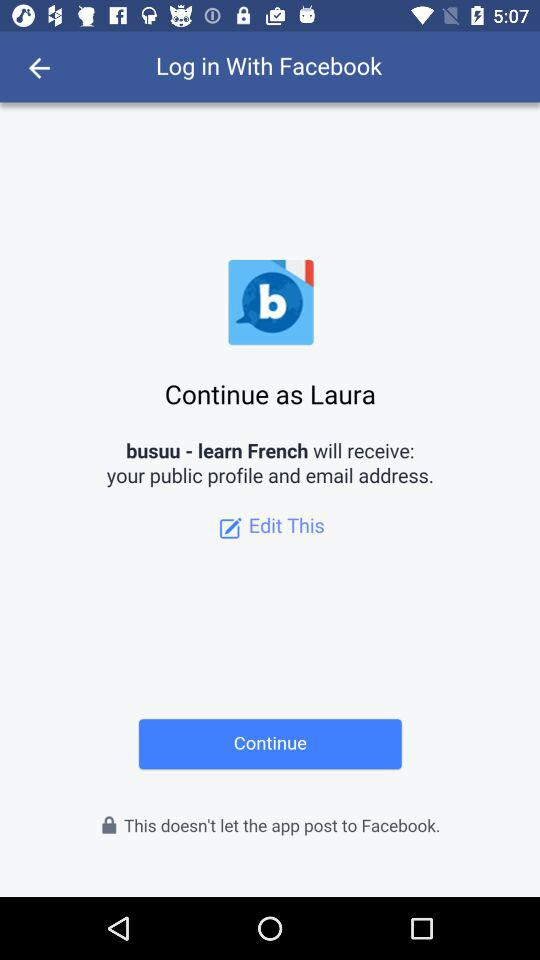What application is asking for permission? The application asking for permission is "busuu - learn French". 